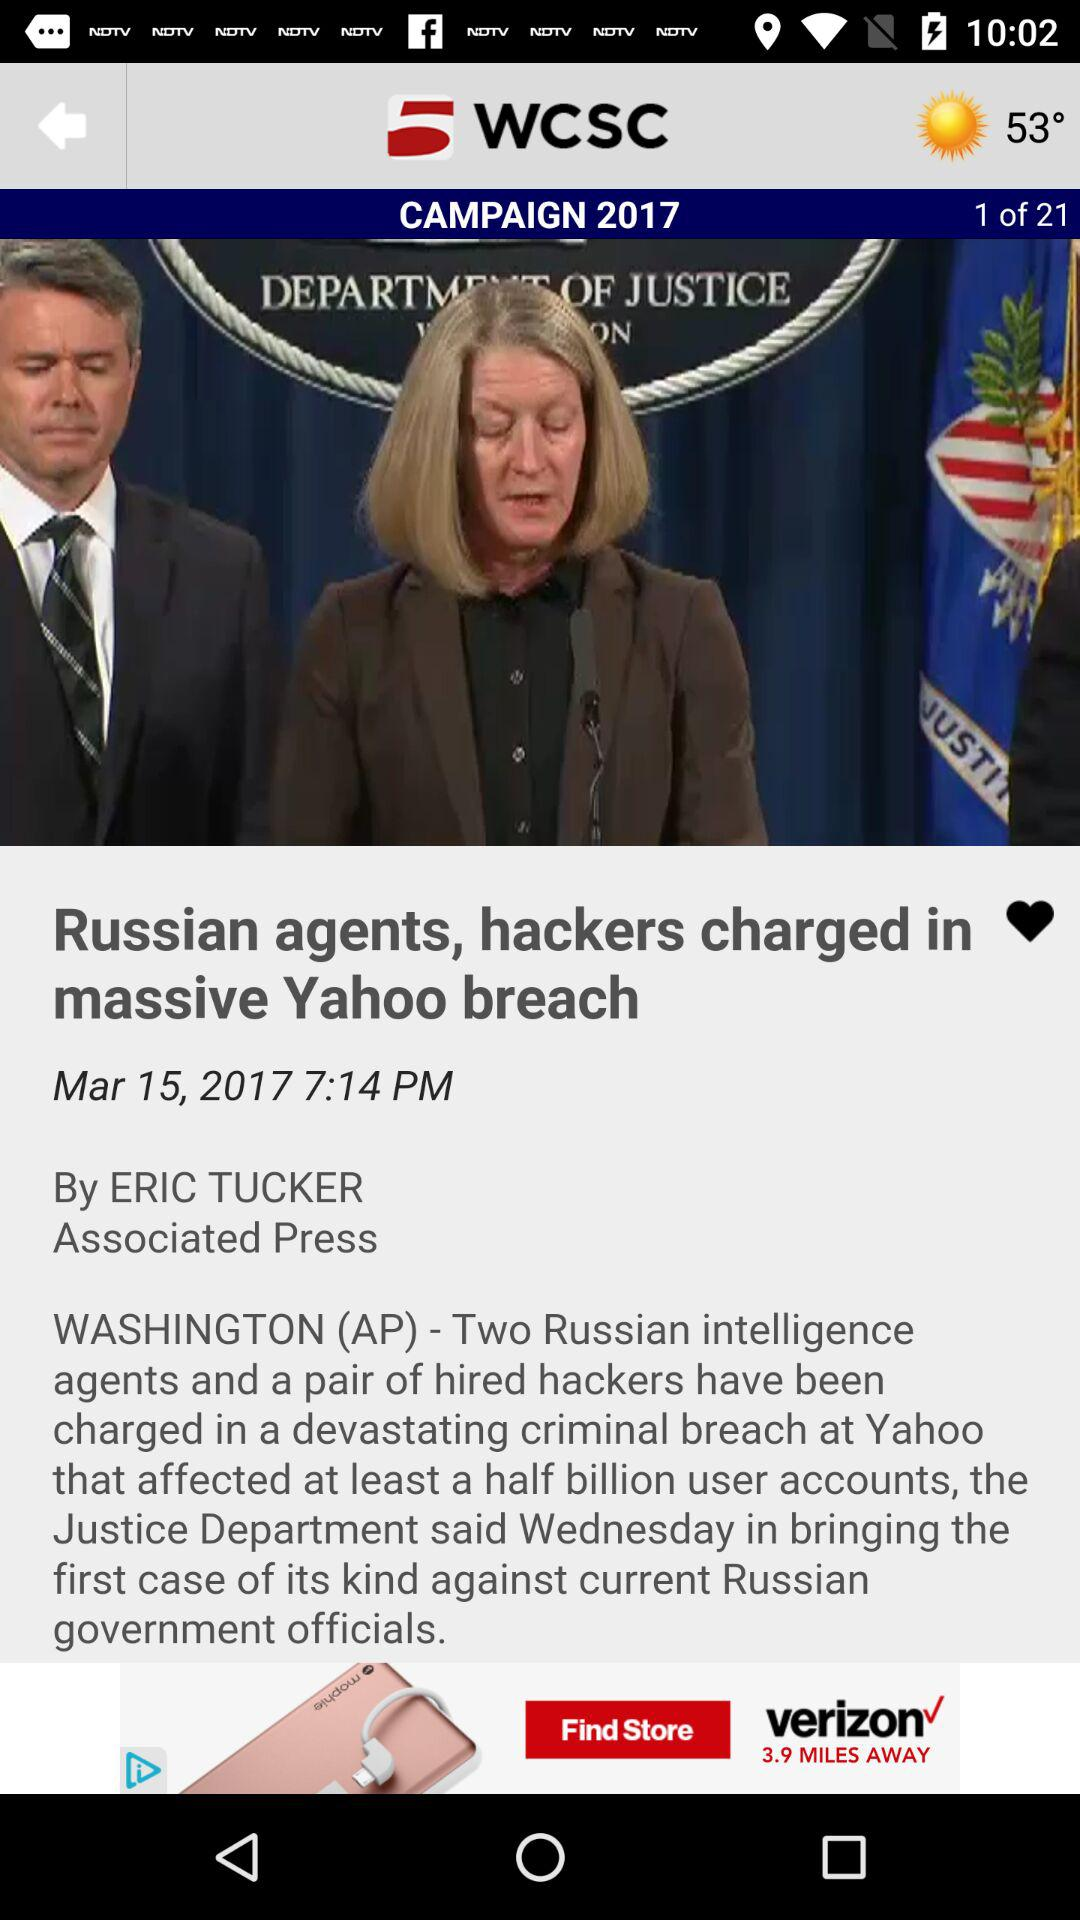What is the total number of pages in the article? There are a total of 21 pages in the article. 